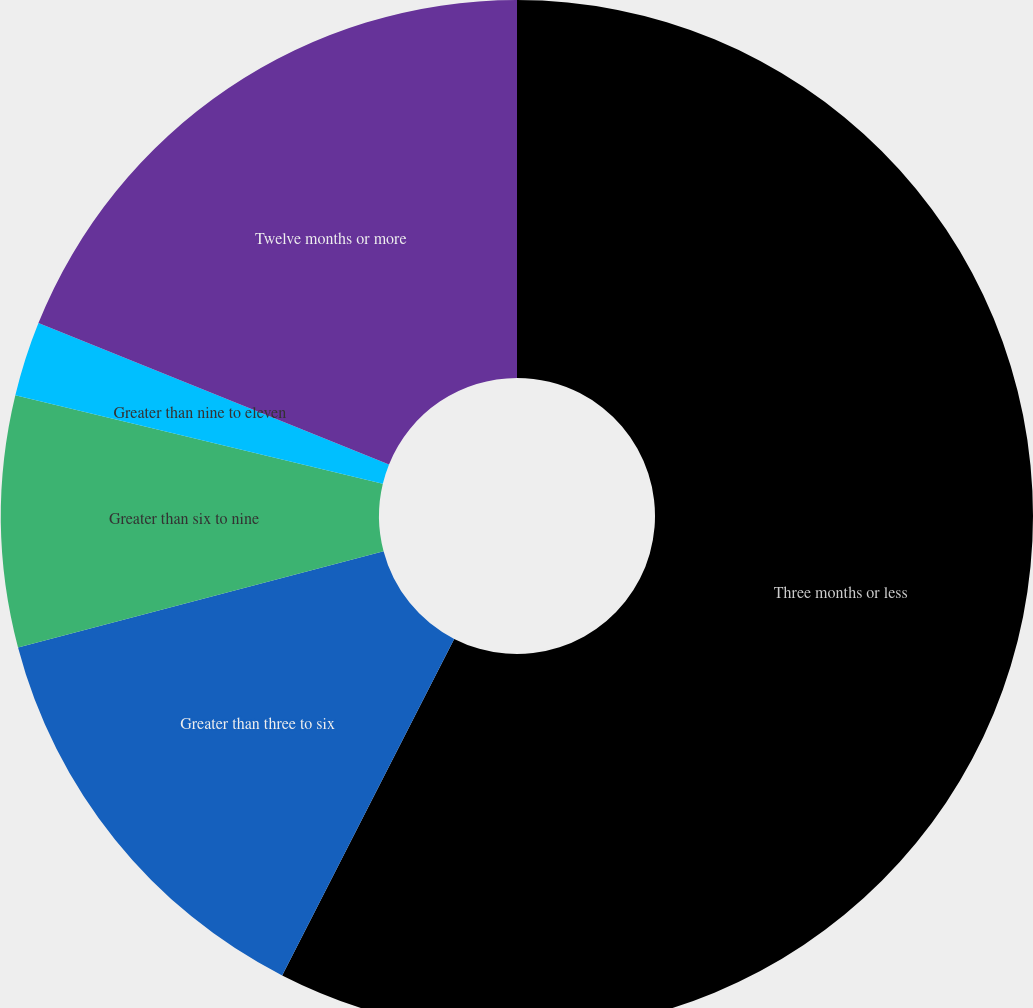Convert chart. <chart><loc_0><loc_0><loc_500><loc_500><pie_chart><fcel>Three months or less<fcel>Greater than three to six<fcel>Greater than six to nine<fcel>Greater than nine to eleven<fcel>Twelve months or more<nl><fcel>57.52%<fcel>13.38%<fcel>7.86%<fcel>2.34%<fcel>18.9%<nl></chart> 